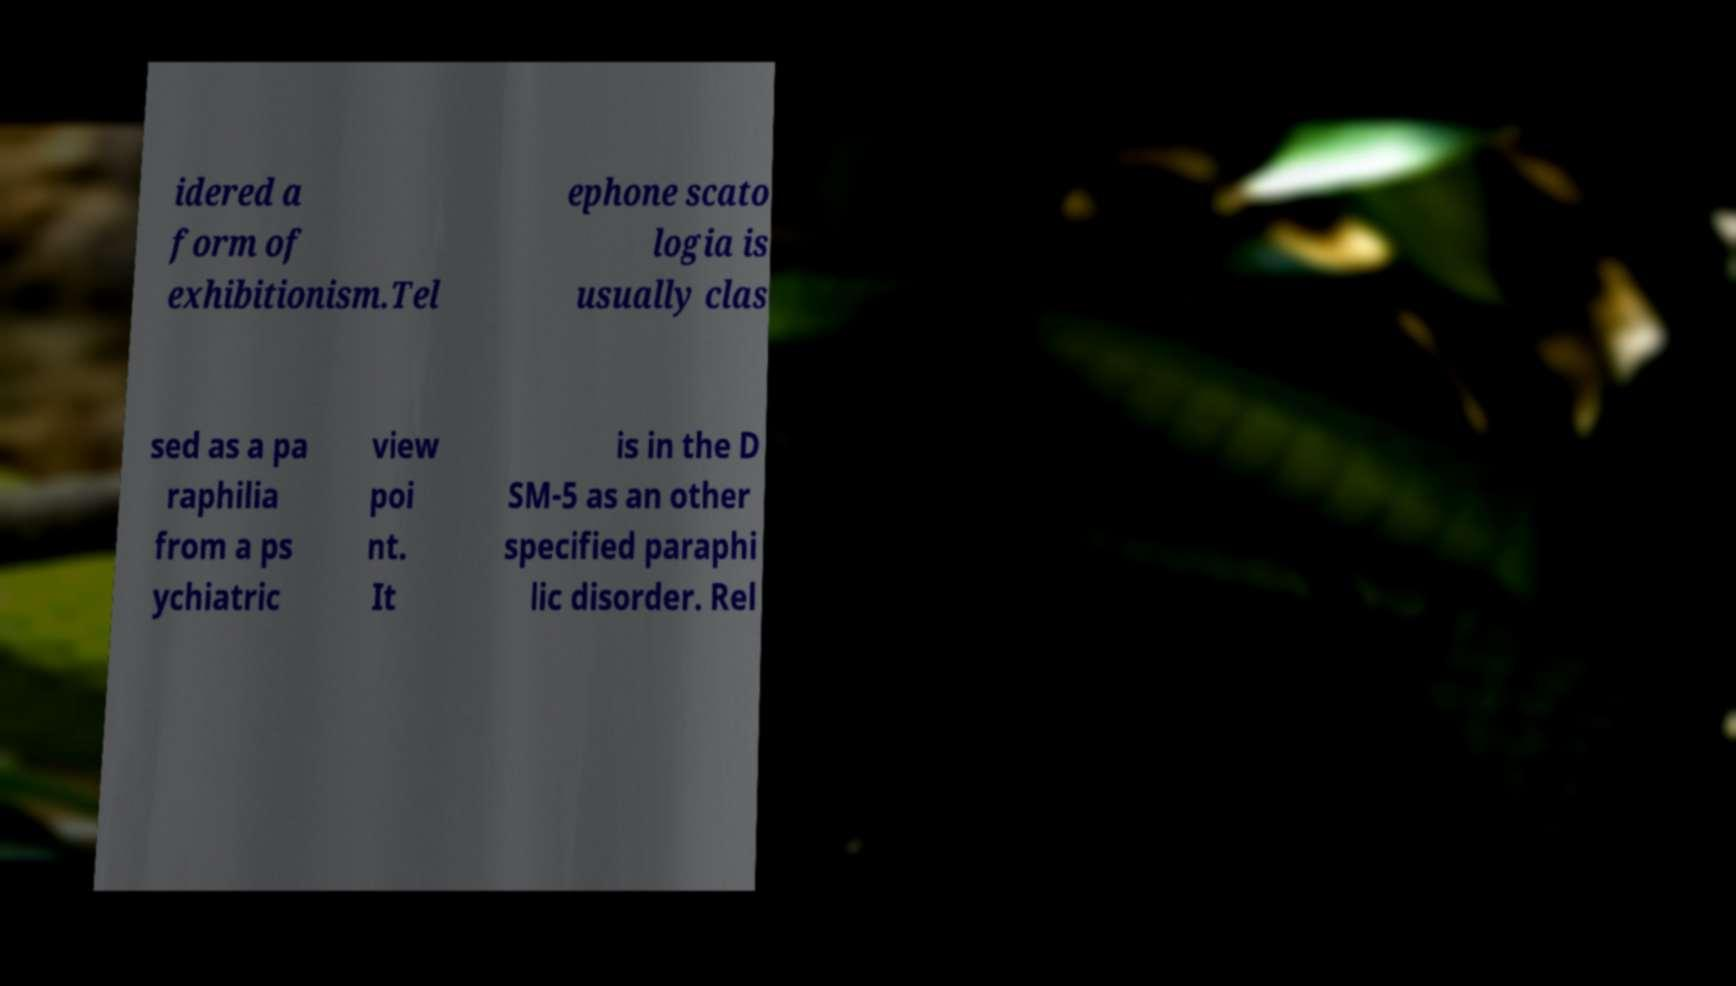There's text embedded in this image that I need extracted. Can you transcribe it verbatim? idered a form of exhibitionism.Tel ephone scato logia is usually clas sed as a pa raphilia from a ps ychiatric view poi nt. It is in the D SM-5 as an other specified paraphi lic disorder. Rel 